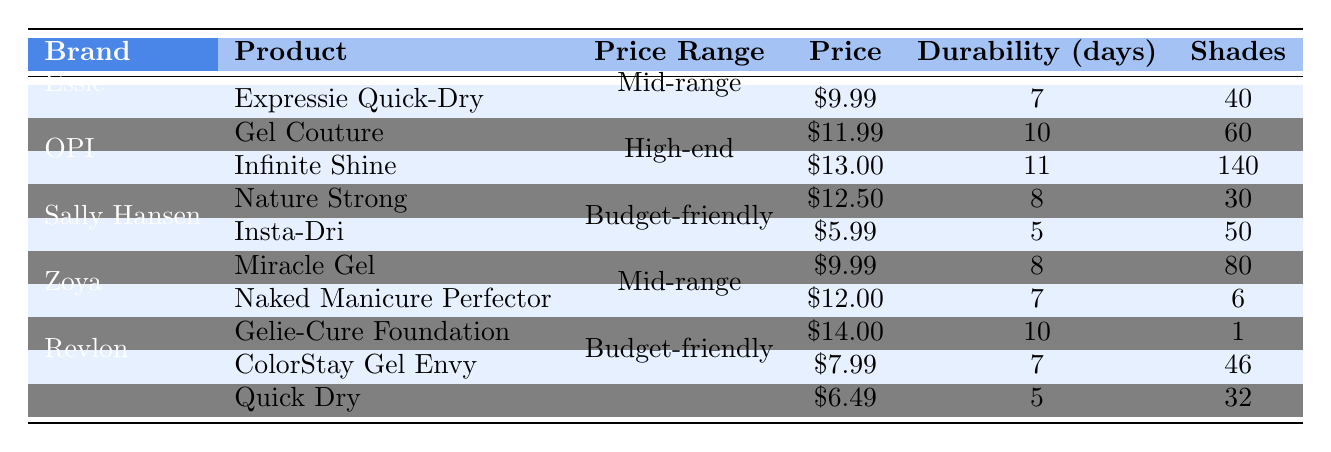What is the price of the "Infinite Shine" product? By looking under the OPI brand, the price associated with "Infinite Shine" is noted as $13.00.
Answer: $13.00 Which brand offers the most shades available for a single-coat nail color? In the OPI brand, "Infinite Shine" offers 140 shades, which is the highest number compared to all other products in the table.
Answer: OPI What is the average durability of Sally Hansen products? For Sally Hansen, the products "Insta-Dri" has a durability of 5 days and "Miracle Gel" has 8 days. The sum is 5 + 8 = 13, and dividing by 2 gives an average of 13 / 2 = 6.5 days.
Answer: 6.5 days Is "Quick Dry" from Revlon more durable than "Insta-Dri" from Sally Hansen? "Quick Dry" has an average durability of 5 days while "Insta-Dri" has 5 days too, so they are equal. Thus, "Quick Dry" is not more durable.
Answer: No How much do you need to spend to buy the most expensive product on the list? The most expensive product is "Gelie-Cure Foundation" offered by Zoya, with a price of $14.00, and that is the total spending required.
Answer: $14.00 Which nail color has the lowest price and what is its average durability? The lowest price is $5.99 for "Insta-Dri," which has an average durability of 5 days. Thus, "Insta-Dri" is the cheapest product with its durability noted.
Answer: $5.99 and 5 days If you want a product with at least 10 days of durability, which brands would you consider? The products with at least 10 days of durability are "Gel Couture" from Essie (10 days), "Infinite Shine" from OPI (11 days), and "Gelie-Cure Foundation" from Zoya (10 days), making Essie, OPI, and Zoya viable brands.
Answer: Essie, OPI, Zoya If you bought all the OPI products, how much would you spend in total? The cost of "Infinite Shine" is $13.00, and "Nature Strong" is $12.50. Summing these, 13 + 12.50 = 25.50 gives the total amount spent.
Answer: $25.50 Which budget-friendly brand has a product with the longest durability? Sally Hansen's "Miracle Gel" has an average durability of 8 days, and Revlon also has "ColorStay Gel Envy" which has a durability of 7 days, making "Miracle Gel" the longest lasting among budget-friendly options.
Answer: Sally Hansen What is the overall average price for all products in the table? The total prices for products listed are $9.99 + $11.99 + $13.00 + $12.50 + $5.99 + $9.99 + $12.00 + $14.00 + $7.99 + $6.49 = $104.94; there are 10 products, so the average is 104.94 / 10 = 10.494.
Answer: $10.49 